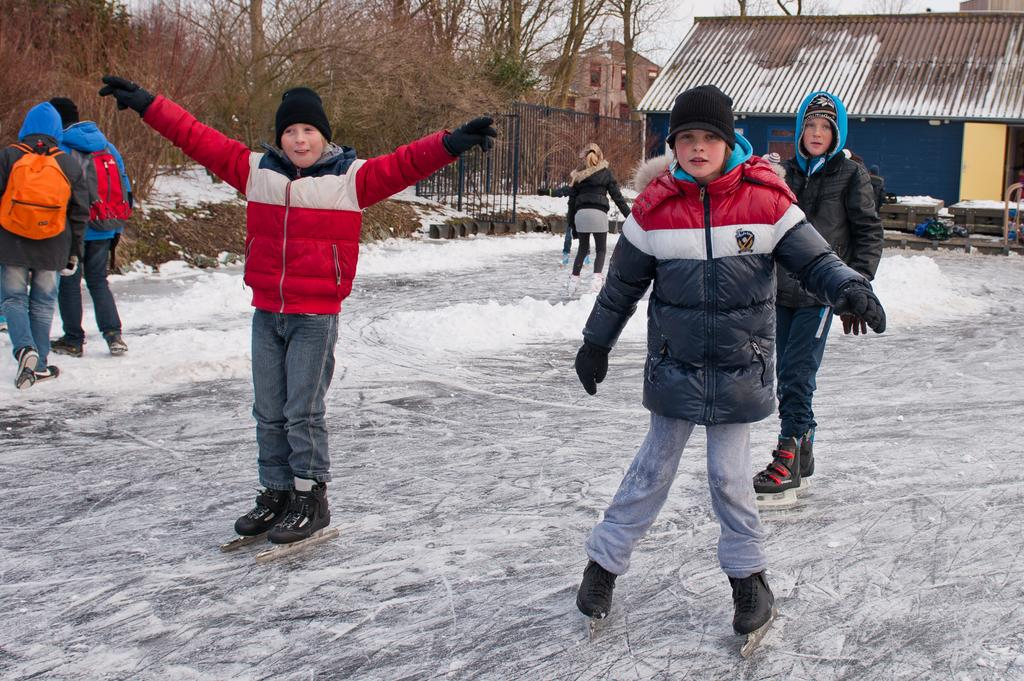What activity is the boy in the middle of the image doing? The boy is doing skating in the middle of the image. What clothing items is the boy wearing while skating? The boy is wearing a coat and a cap. Are there any other people doing the same activity in the image? Yes, there are other people doing skating on the left side of the image. What type of surface is the skating taking place on? The skating is taking place on snow. What structure can be seen on the right side of the image? There is an iron shed on the right side of the image. What type of fear can be seen on the faces of the people in the image? There is no indication of fear on the faces of the people in the image; they appear to be enjoying skating. 